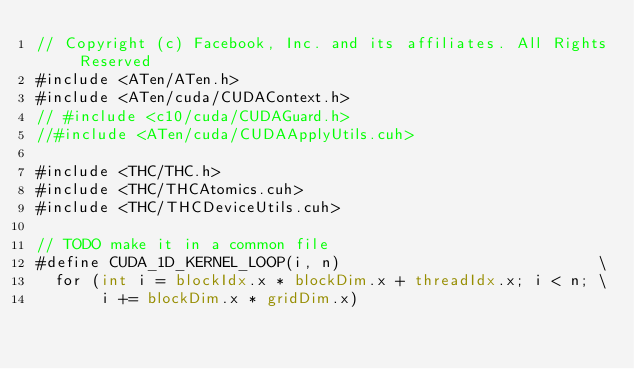<code> <loc_0><loc_0><loc_500><loc_500><_Cuda_>// Copyright (c) Facebook, Inc. and its affiliates. All Rights Reserved
#include <ATen/ATen.h>
#include <ATen/cuda/CUDAContext.h>
// #include <c10/cuda/CUDAGuard.h>
//#include <ATen/cuda/CUDAApplyUtils.cuh>

#include <THC/THC.h>
#include <THC/THCAtomics.cuh>
#include <THC/THCDeviceUtils.cuh>

// TODO make it in a common file
#define CUDA_1D_KERNEL_LOOP(i, n)                            \
  for (int i = blockIdx.x * blockDim.x + threadIdx.x; i < n; \
       i += blockDim.x * gridDim.x)
</code> 